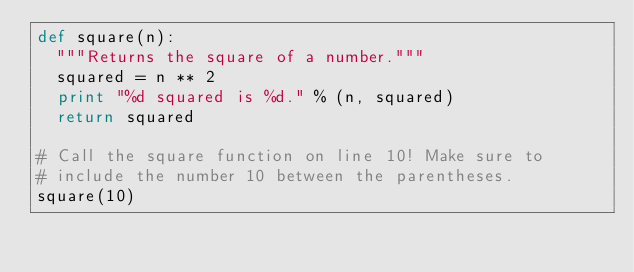Convert code to text. <code><loc_0><loc_0><loc_500><loc_500><_Python_>def square(n):
  """Returns the square of a number."""
  squared = n ** 2
  print "%d squared is %d." % (n, squared)
  return squared
  
# Call the square function on line 10! Make sure to
# include the number 10 between the parentheses.
square(10)
</code> 